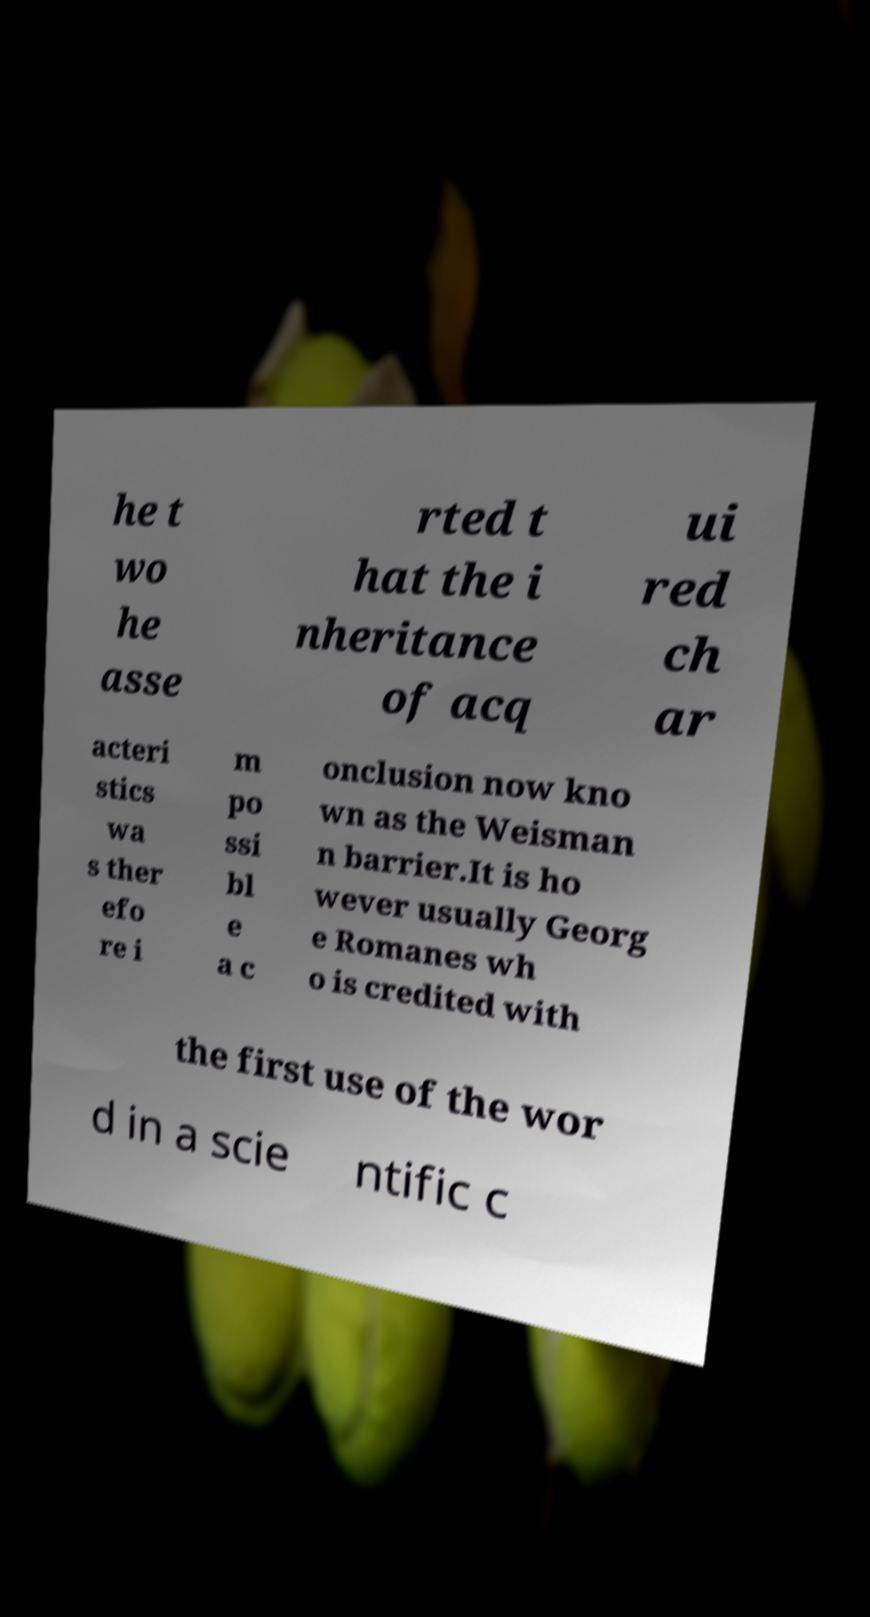There's text embedded in this image that I need extracted. Can you transcribe it verbatim? he t wo he asse rted t hat the i nheritance of acq ui red ch ar acteri stics wa s ther efo re i m po ssi bl e a c onclusion now kno wn as the Weisman n barrier.It is ho wever usually Georg e Romanes wh o is credited with the first use of the wor d in a scie ntific c 